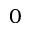Convert formula to latex. <formula><loc_0><loc_0><loc_500><loc_500>0</formula> 